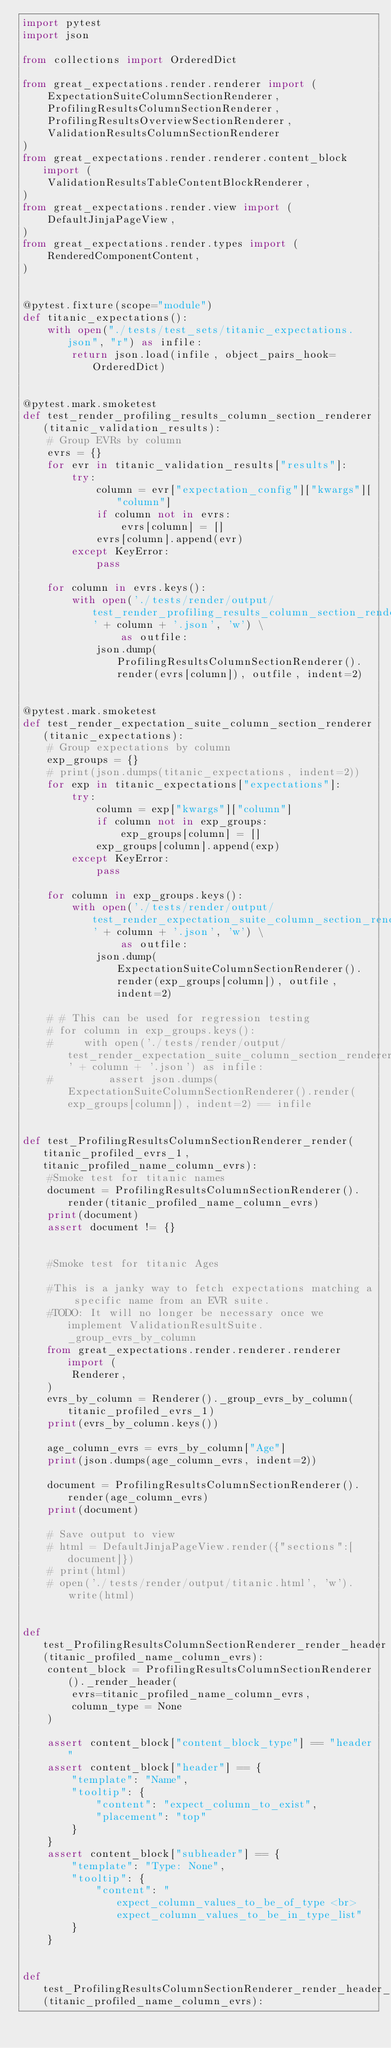Convert code to text. <code><loc_0><loc_0><loc_500><loc_500><_Python_>import pytest
import json

from collections import OrderedDict

from great_expectations.render.renderer import (
    ExpectationSuiteColumnSectionRenderer,
    ProfilingResultsColumnSectionRenderer,
    ProfilingResultsOverviewSectionRenderer,
    ValidationResultsColumnSectionRenderer
)
from great_expectations.render.renderer.content_block import (
    ValidationResultsTableContentBlockRenderer,
)
from great_expectations.render.view import (
    DefaultJinjaPageView,
)
from great_expectations.render.types import (
    RenderedComponentContent,
)


@pytest.fixture(scope="module")
def titanic_expectations():
    with open("./tests/test_sets/titanic_expectations.json", "r") as infile:
        return json.load(infile, object_pairs_hook=OrderedDict)


@pytest.mark.smoketest
def test_render_profiling_results_column_section_renderer(titanic_validation_results):
    # Group EVRs by column
    evrs = {}
    for evr in titanic_validation_results["results"]:
        try:
            column = evr["expectation_config"]["kwargs"]["column"]
            if column not in evrs:
                evrs[column] = []
            evrs[column].append(evr)
        except KeyError:
            pass

    for column in evrs.keys():
        with open('./tests/render/output/test_render_profiling_results_column_section_renderer__' + column + '.json', 'w') \
                as outfile:
            json.dump(ProfilingResultsColumnSectionRenderer().render(evrs[column]), outfile, indent=2)


@pytest.mark.smoketest
def test_render_expectation_suite_column_section_renderer(titanic_expectations):
    # Group expectations by column
    exp_groups = {}
    # print(json.dumps(titanic_expectations, indent=2))
    for exp in titanic_expectations["expectations"]:
        try:
            column = exp["kwargs"]["column"]
            if column not in exp_groups:
                exp_groups[column] = []
            exp_groups[column].append(exp)
        except KeyError:
            pass

    for column in exp_groups.keys():
        with open('./tests/render/output/test_render_expectation_suite_column_section_renderer' + column + '.json', 'w') \
                as outfile:
            json.dump(ExpectationSuiteColumnSectionRenderer().render(exp_groups[column]), outfile, indent=2)

    # # This can be used for regression testing
    # for column in exp_groups.keys():
    #     with open('./tests/render/output/test_render_expectation_suite_column_section_renderer' + column + '.json') as infile:
    #         assert json.dumps(ExpectationSuiteColumnSectionRenderer().render(exp_groups[column]), indent=2) == infile


def test_ProfilingResultsColumnSectionRenderer_render(titanic_profiled_evrs_1, titanic_profiled_name_column_evrs):
    #Smoke test for titanic names
    document = ProfilingResultsColumnSectionRenderer().render(titanic_profiled_name_column_evrs)
    print(document)
    assert document != {}


    #Smoke test for titanic Ages

    #This is a janky way to fetch expectations matching a specific name from an EVR suite.
    #TODO: It will no longer be necessary once we implement ValidationResultSuite._group_evrs_by_column
    from great_expectations.render.renderer.renderer import (
        Renderer,
    )
    evrs_by_column = Renderer()._group_evrs_by_column(titanic_profiled_evrs_1)
    print(evrs_by_column.keys())

    age_column_evrs = evrs_by_column["Age"]
    print(json.dumps(age_column_evrs, indent=2))

    document = ProfilingResultsColumnSectionRenderer().render(age_column_evrs)
    print(document)

    # Save output to view
    # html = DefaultJinjaPageView.render({"sections":[document]})
    # print(html)
    # open('./tests/render/output/titanic.html', 'w').write(html)


def test_ProfilingResultsColumnSectionRenderer_render_header(titanic_profiled_name_column_evrs):
    content_block = ProfilingResultsColumnSectionRenderer()._render_header(
        evrs=titanic_profiled_name_column_evrs,
        column_type = None
    )

    assert content_block["content_block_type"] == "header"
    assert content_block["header"] == {
        "template": "Name",
        "tooltip": {
            "content": "expect_column_to_exist",
            "placement": "top"
        }
    }
    assert content_block["subheader"] == {
        "template": "Type: None",
        "tooltip": {
            "content": "expect_column_values_to_be_of_type <br>expect_column_values_to_be_in_type_list"
        }
    }


def test_ProfilingResultsColumnSectionRenderer_render_header_with_unescaped_dollar_sign(titanic_profiled_name_column_evrs):</code> 